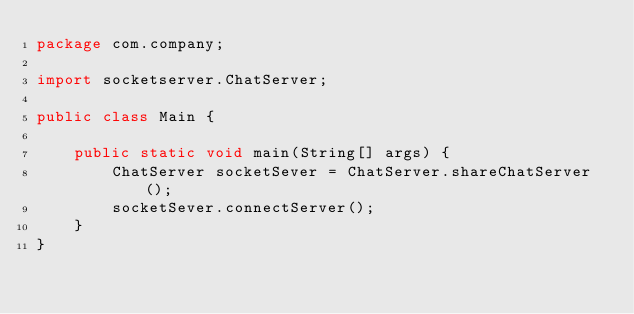<code> <loc_0><loc_0><loc_500><loc_500><_Java_>package com.company;

import socketserver.ChatServer;

public class Main {

    public static void main(String[] args) {
        ChatServer socketSever = ChatServer.shareChatServer();
        socketSever.connectServer();
    }
}
</code> 